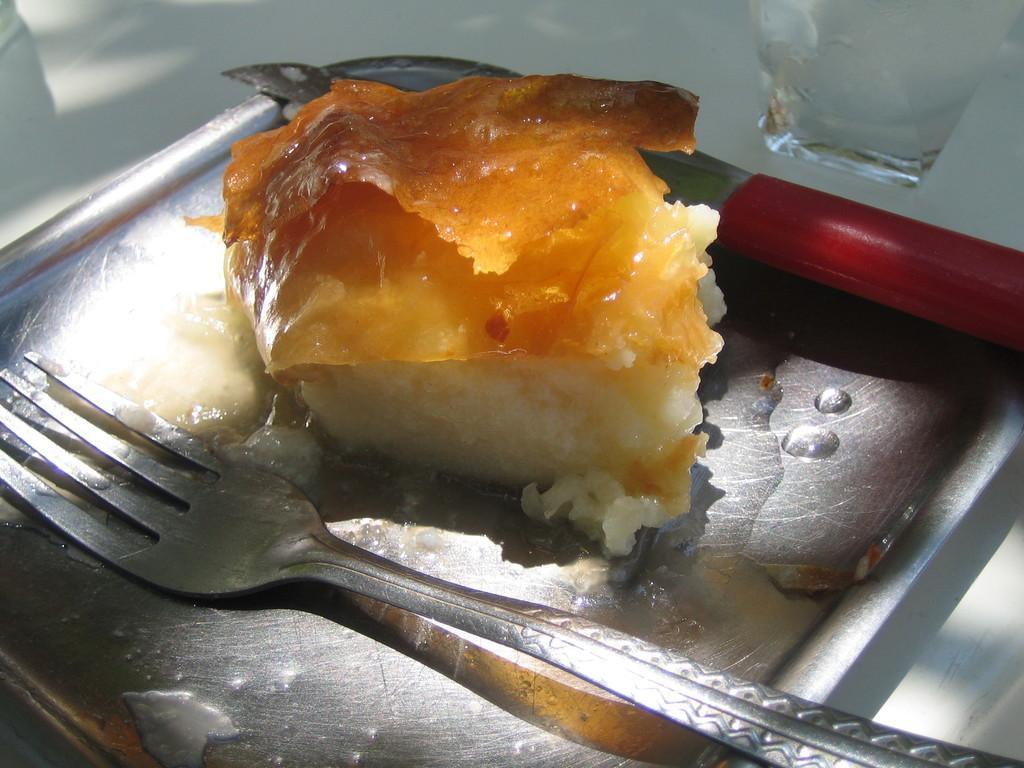What is on the plate in the image? There is a food item on a plate in the image. What utensils are present in the image? There is a fork and a knife in the image. What is the glass used for in the image? The glass is likely used for holding a beverage. What type of brass instrument can be seen in the image? There is no brass instrument present in the image. What thoughts are being expressed by the food item on the plate? Food items do not have thoughts, so this cannot be determined from the image. 